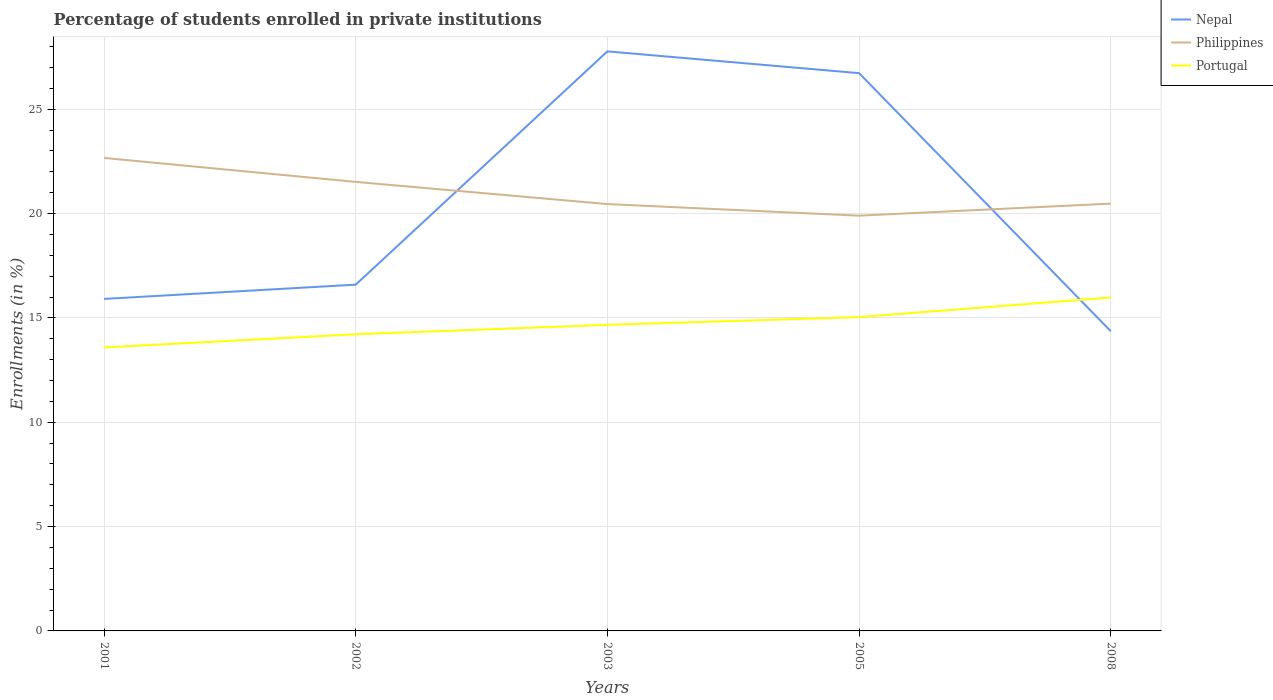Across all years, what is the maximum percentage of trained teachers in Philippines?
Your response must be concise. 19.9. In which year was the percentage of trained teachers in Portugal maximum?
Make the answer very short. 2001. What is the total percentage of trained teachers in Portugal in the graph?
Offer a very short reply. -2.39. What is the difference between the highest and the second highest percentage of trained teachers in Portugal?
Provide a short and direct response. 2.39. How many lines are there?
Your response must be concise. 3. Are the values on the major ticks of Y-axis written in scientific E-notation?
Your answer should be very brief. No. Does the graph contain any zero values?
Offer a very short reply. No. Does the graph contain grids?
Keep it short and to the point. Yes. Where does the legend appear in the graph?
Provide a short and direct response. Top right. How are the legend labels stacked?
Provide a short and direct response. Vertical. What is the title of the graph?
Provide a short and direct response. Percentage of students enrolled in private institutions. Does "Cabo Verde" appear as one of the legend labels in the graph?
Your answer should be compact. No. What is the label or title of the Y-axis?
Give a very brief answer. Enrollments (in %). What is the Enrollments (in %) in Nepal in 2001?
Keep it short and to the point. 15.91. What is the Enrollments (in %) in Philippines in 2001?
Provide a succinct answer. 22.67. What is the Enrollments (in %) in Portugal in 2001?
Your answer should be compact. 13.58. What is the Enrollments (in %) in Nepal in 2002?
Your answer should be compact. 16.59. What is the Enrollments (in %) in Philippines in 2002?
Offer a very short reply. 21.52. What is the Enrollments (in %) of Portugal in 2002?
Your answer should be very brief. 14.22. What is the Enrollments (in %) of Nepal in 2003?
Ensure brevity in your answer.  27.77. What is the Enrollments (in %) of Philippines in 2003?
Ensure brevity in your answer.  20.45. What is the Enrollments (in %) of Portugal in 2003?
Your response must be concise. 14.67. What is the Enrollments (in %) of Nepal in 2005?
Make the answer very short. 26.73. What is the Enrollments (in %) of Philippines in 2005?
Keep it short and to the point. 19.9. What is the Enrollments (in %) in Portugal in 2005?
Offer a terse response. 15.04. What is the Enrollments (in %) in Nepal in 2008?
Offer a very short reply. 14.36. What is the Enrollments (in %) of Philippines in 2008?
Your answer should be compact. 20.48. What is the Enrollments (in %) of Portugal in 2008?
Offer a very short reply. 15.98. Across all years, what is the maximum Enrollments (in %) of Nepal?
Provide a short and direct response. 27.77. Across all years, what is the maximum Enrollments (in %) of Philippines?
Your answer should be compact. 22.67. Across all years, what is the maximum Enrollments (in %) of Portugal?
Your response must be concise. 15.98. Across all years, what is the minimum Enrollments (in %) in Nepal?
Provide a short and direct response. 14.36. Across all years, what is the minimum Enrollments (in %) of Philippines?
Your response must be concise. 19.9. Across all years, what is the minimum Enrollments (in %) of Portugal?
Provide a short and direct response. 13.58. What is the total Enrollments (in %) in Nepal in the graph?
Your answer should be compact. 101.36. What is the total Enrollments (in %) of Philippines in the graph?
Make the answer very short. 105.01. What is the total Enrollments (in %) of Portugal in the graph?
Give a very brief answer. 73.48. What is the difference between the Enrollments (in %) of Nepal in 2001 and that in 2002?
Your response must be concise. -0.68. What is the difference between the Enrollments (in %) of Philippines in 2001 and that in 2002?
Keep it short and to the point. 1.15. What is the difference between the Enrollments (in %) in Portugal in 2001 and that in 2002?
Offer a very short reply. -0.63. What is the difference between the Enrollments (in %) of Nepal in 2001 and that in 2003?
Offer a terse response. -11.86. What is the difference between the Enrollments (in %) in Philippines in 2001 and that in 2003?
Your answer should be very brief. 2.21. What is the difference between the Enrollments (in %) of Portugal in 2001 and that in 2003?
Ensure brevity in your answer.  -1.08. What is the difference between the Enrollments (in %) of Nepal in 2001 and that in 2005?
Your response must be concise. -10.82. What is the difference between the Enrollments (in %) in Philippines in 2001 and that in 2005?
Your response must be concise. 2.77. What is the difference between the Enrollments (in %) in Portugal in 2001 and that in 2005?
Offer a terse response. -1.45. What is the difference between the Enrollments (in %) in Nepal in 2001 and that in 2008?
Offer a very short reply. 1.55. What is the difference between the Enrollments (in %) in Philippines in 2001 and that in 2008?
Offer a terse response. 2.19. What is the difference between the Enrollments (in %) of Portugal in 2001 and that in 2008?
Keep it short and to the point. -2.39. What is the difference between the Enrollments (in %) in Nepal in 2002 and that in 2003?
Make the answer very short. -11.18. What is the difference between the Enrollments (in %) in Philippines in 2002 and that in 2003?
Your answer should be very brief. 1.06. What is the difference between the Enrollments (in %) of Portugal in 2002 and that in 2003?
Your answer should be compact. -0.45. What is the difference between the Enrollments (in %) in Nepal in 2002 and that in 2005?
Make the answer very short. -10.14. What is the difference between the Enrollments (in %) of Philippines in 2002 and that in 2005?
Make the answer very short. 1.62. What is the difference between the Enrollments (in %) of Portugal in 2002 and that in 2005?
Your answer should be compact. -0.82. What is the difference between the Enrollments (in %) of Nepal in 2002 and that in 2008?
Provide a succinct answer. 2.23. What is the difference between the Enrollments (in %) of Philippines in 2002 and that in 2008?
Offer a terse response. 1.04. What is the difference between the Enrollments (in %) of Portugal in 2002 and that in 2008?
Make the answer very short. -1.76. What is the difference between the Enrollments (in %) of Nepal in 2003 and that in 2005?
Provide a succinct answer. 1.04. What is the difference between the Enrollments (in %) in Philippines in 2003 and that in 2005?
Offer a very short reply. 0.56. What is the difference between the Enrollments (in %) in Portugal in 2003 and that in 2005?
Ensure brevity in your answer.  -0.37. What is the difference between the Enrollments (in %) of Nepal in 2003 and that in 2008?
Keep it short and to the point. 13.41. What is the difference between the Enrollments (in %) of Philippines in 2003 and that in 2008?
Offer a very short reply. -0.02. What is the difference between the Enrollments (in %) in Portugal in 2003 and that in 2008?
Ensure brevity in your answer.  -1.31. What is the difference between the Enrollments (in %) in Nepal in 2005 and that in 2008?
Offer a very short reply. 12.37. What is the difference between the Enrollments (in %) of Philippines in 2005 and that in 2008?
Your answer should be very brief. -0.58. What is the difference between the Enrollments (in %) of Portugal in 2005 and that in 2008?
Your response must be concise. -0.94. What is the difference between the Enrollments (in %) of Nepal in 2001 and the Enrollments (in %) of Philippines in 2002?
Your response must be concise. -5.61. What is the difference between the Enrollments (in %) of Nepal in 2001 and the Enrollments (in %) of Portugal in 2002?
Offer a terse response. 1.69. What is the difference between the Enrollments (in %) in Philippines in 2001 and the Enrollments (in %) in Portugal in 2002?
Give a very brief answer. 8.45. What is the difference between the Enrollments (in %) in Nepal in 2001 and the Enrollments (in %) in Philippines in 2003?
Provide a short and direct response. -4.54. What is the difference between the Enrollments (in %) of Nepal in 2001 and the Enrollments (in %) of Portugal in 2003?
Offer a terse response. 1.24. What is the difference between the Enrollments (in %) in Philippines in 2001 and the Enrollments (in %) in Portugal in 2003?
Provide a succinct answer. 8. What is the difference between the Enrollments (in %) in Nepal in 2001 and the Enrollments (in %) in Philippines in 2005?
Provide a succinct answer. -3.99. What is the difference between the Enrollments (in %) in Nepal in 2001 and the Enrollments (in %) in Portugal in 2005?
Your answer should be very brief. 0.87. What is the difference between the Enrollments (in %) in Philippines in 2001 and the Enrollments (in %) in Portugal in 2005?
Your answer should be compact. 7.63. What is the difference between the Enrollments (in %) in Nepal in 2001 and the Enrollments (in %) in Philippines in 2008?
Provide a succinct answer. -4.57. What is the difference between the Enrollments (in %) of Nepal in 2001 and the Enrollments (in %) of Portugal in 2008?
Give a very brief answer. -0.07. What is the difference between the Enrollments (in %) of Philippines in 2001 and the Enrollments (in %) of Portugal in 2008?
Provide a short and direct response. 6.69. What is the difference between the Enrollments (in %) in Nepal in 2002 and the Enrollments (in %) in Philippines in 2003?
Keep it short and to the point. -3.86. What is the difference between the Enrollments (in %) in Nepal in 2002 and the Enrollments (in %) in Portugal in 2003?
Your answer should be compact. 1.93. What is the difference between the Enrollments (in %) in Philippines in 2002 and the Enrollments (in %) in Portugal in 2003?
Keep it short and to the point. 6.85. What is the difference between the Enrollments (in %) in Nepal in 2002 and the Enrollments (in %) in Philippines in 2005?
Your answer should be compact. -3.31. What is the difference between the Enrollments (in %) in Nepal in 2002 and the Enrollments (in %) in Portugal in 2005?
Provide a short and direct response. 1.56. What is the difference between the Enrollments (in %) in Philippines in 2002 and the Enrollments (in %) in Portugal in 2005?
Offer a very short reply. 6.48. What is the difference between the Enrollments (in %) in Nepal in 2002 and the Enrollments (in %) in Philippines in 2008?
Your answer should be compact. -3.88. What is the difference between the Enrollments (in %) of Nepal in 2002 and the Enrollments (in %) of Portugal in 2008?
Give a very brief answer. 0.61. What is the difference between the Enrollments (in %) in Philippines in 2002 and the Enrollments (in %) in Portugal in 2008?
Offer a very short reply. 5.54. What is the difference between the Enrollments (in %) in Nepal in 2003 and the Enrollments (in %) in Philippines in 2005?
Keep it short and to the point. 7.87. What is the difference between the Enrollments (in %) in Nepal in 2003 and the Enrollments (in %) in Portugal in 2005?
Offer a terse response. 12.73. What is the difference between the Enrollments (in %) of Philippines in 2003 and the Enrollments (in %) of Portugal in 2005?
Offer a terse response. 5.42. What is the difference between the Enrollments (in %) in Nepal in 2003 and the Enrollments (in %) in Philippines in 2008?
Keep it short and to the point. 7.3. What is the difference between the Enrollments (in %) of Nepal in 2003 and the Enrollments (in %) of Portugal in 2008?
Your answer should be compact. 11.79. What is the difference between the Enrollments (in %) of Philippines in 2003 and the Enrollments (in %) of Portugal in 2008?
Keep it short and to the point. 4.48. What is the difference between the Enrollments (in %) of Nepal in 2005 and the Enrollments (in %) of Philippines in 2008?
Your answer should be compact. 6.25. What is the difference between the Enrollments (in %) of Nepal in 2005 and the Enrollments (in %) of Portugal in 2008?
Your response must be concise. 10.75. What is the difference between the Enrollments (in %) in Philippines in 2005 and the Enrollments (in %) in Portugal in 2008?
Your answer should be very brief. 3.92. What is the average Enrollments (in %) in Nepal per year?
Your answer should be very brief. 20.27. What is the average Enrollments (in %) of Philippines per year?
Provide a short and direct response. 21. What is the average Enrollments (in %) of Portugal per year?
Give a very brief answer. 14.7. In the year 2001, what is the difference between the Enrollments (in %) in Nepal and Enrollments (in %) in Philippines?
Offer a very short reply. -6.76. In the year 2001, what is the difference between the Enrollments (in %) in Nepal and Enrollments (in %) in Portugal?
Make the answer very short. 2.33. In the year 2001, what is the difference between the Enrollments (in %) in Philippines and Enrollments (in %) in Portugal?
Make the answer very short. 9.08. In the year 2002, what is the difference between the Enrollments (in %) in Nepal and Enrollments (in %) in Philippines?
Your answer should be very brief. -4.92. In the year 2002, what is the difference between the Enrollments (in %) in Nepal and Enrollments (in %) in Portugal?
Ensure brevity in your answer.  2.38. In the year 2002, what is the difference between the Enrollments (in %) in Philippines and Enrollments (in %) in Portugal?
Keep it short and to the point. 7.3. In the year 2003, what is the difference between the Enrollments (in %) of Nepal and Enrollments (in %) of Philippines?
Provide a short and direct response. 7.32. In the year 2003, what is the difference between the Enrollments (in %) of Nepal and Enrollments (in %) of Portugal?
Keep it short and to the point. 13.1. In the year 2003, what is the difference between the Enrollments (in %) in Philippines and Enrollments (in %) in Portugal?
Give a very brief answer. 5.79. In the year 2005, what is the difference between the Enrollments (in %) of Nepal and Enrollments (in %) of Philippines?
Your answer should be compact. 6.83. In the year 2005, what is the difference between the Enrollments (in %) of Nepal and Enrollments (in %) of Portugal?
Keep it short and to the point. 11.69. In the year 2005, what is the difference between the Enrollments (in %) in Philippines and Enrollments (in %) in Portugal?
Offer a very short reply. 4.86. In the year 2008, what is the difference between the Enrollments (in %) of Nepal and Enrollments (in %) of Philippines?
Give a very brief answer. -6.11. In the year 2008, what is the difference between the Enrollments (in %) in Nepal and Enrollments (in %) in Portugal?
Your answer should be compact. -1.62. In the year 2008, what is the difference between the Enrollments (in %) of Philippines and Enrollments (in %) of Portugal?
Keep it short and to the point. 4.5. What is the ratio of the Enrollments (in %) of Nepal in 2001 to that in 2002?
Your answer should be compact. 0.96. What is the ratio of the Enrollments (in %) of Philippines in 2001 to that in 2002?
Provide a short and direct response. 1.05. What is the ratio of the Enrollments (in %) in Portugal in 2001 to that in 2002?
Keep it short and to the point. 0.96. What is the ratio of the Enrollments (in %) in Nepal in 2001 to that in 2003?
Offer a very short reply. 0.57. What is the ratio of the Enrollments (in %) of Philippines in 2001 to that in 2003?
Keep it short and to the point. 1.11. What is the ratio of the Enrollments (in %) of Portugal in 2001 to that in 2003?
Offer a very short reply. 0.93. What is the ratio of the Enrollments (in %) in Nepal in 2001 to that in 2005?
Give a very brief answer. 0.6. What is the ratio of the Enrollments (in %) of Philippines in 2001 to that in 2005?
Provide a succinct answer. 1.14. What is the ratio of the Enrollments (in %) of Portugal in 2001 to that in 2005?
Keep it short and to the point. 0.9. What is the ratio of the Enrollments (in %) of Nepal in 2001 to that in 2008?
Your answer should be compact. 1.11. What is the ratio of the Enrollments (in %) in Philippines in 2001 to that in 2008?
Give a very brief answer. 1.11. What is the ratio of the Enrollments (in %) of Portugal in 2001 to that in 2008?
Provide a short and direct response. 0.85. What is the ratio of the Enrollments (in %) in Nepal in 2002 to that in 2003?
Give a very brief answer. 0.6. What is the ratio of the Enrollments (in %) in Philippines in 2002 to that in 2003?
Provide a short and direct response. 1.05. What is the ratio of the Enrollments (in %) in Portugal in 2002 to that in 2003?
Offer a very short reply. 0.97. What is the ratio of the Enrollments (in %) of Nepal in 2002 to that in 2005?
Your answer should be compact. 0.62. What is the ratio of the Enrollments (in %) in Philippines in 2002 to that in 2005?
Make the answer very short. 1.08. What is the ratio of the Enrollments (in %) in Portugal in 2002 to that in 2005?
Your response must be concise. 0.95. What is the ratio of the Enrollments (in %) in Nepal in 2002 to that in 2008?
Offer a very short reply. 1.16. What is the ratio of the Enrollments (in %) in Philippines in 2002 to that in 2008?
Give a very brief answer. 1.05. What is the ratio of the Enrollments (in %) of Portugal in 2002 to that in 2008?
Offer a terse response. 0.89. What is the ratio of the Enrollments (in %) of Nepal in 2003 to that in 2005?
Provide a short and direct response. 1.04. What is the ratio of the Enrollments (in %) in Philippines in 2003 to that in 2005?
Your response must be concise. 1.03. What is the ratio of the Enrollments (in %) in Portugal in 2003 to that in 2005?
Your response must be concise. 0.98. What is the ratio of the Enrollments (in %) of Nepal in 2003 to that in 2008?
Ensure brevity in your answer.  1.93. What is the ratio of the Enrollments (in %) of Portugal in 2003 to that in 2008?
Offer a terse response. 0.92. What is the ratio of the Enrollments (in %) of Nepal in 2005 to that in 2008?
Ensure brevity in your answer.  1.86. What is the ratio of the Enrollments (in %) in Philippines in 2005 to that in 2008?
Offer a very short reply. 0.97. What is the ratio of the Enrollments (in %) of Portugal in 2005 to that in 2008?
Provide a succinct answer. 0.94. What is the difference between the highest and the second highest Enrollments (in %) of Nepal?
Offer a very short reply. 1.04. What is the difference between the highest and the second highest Enrollments (in %) in Philippines?
Your answer should be compact. 1.15. What is the difference between the highest and the second highest Enrollments (in %) in Portugal?
Make the answer very short. 0.94. What is the difference between the highest and the lowest Enrollments (in %) of Nepal?
Your answer should be compact. 13.41. What is the difference between the highest and the lowest Enrollments (in %) of Philippines?
Give a very brief answer. 2.77. What is the difference between the highest and the lowest Enrollments (in %) in Portugal?
Your answer should be compact. 2.39. 